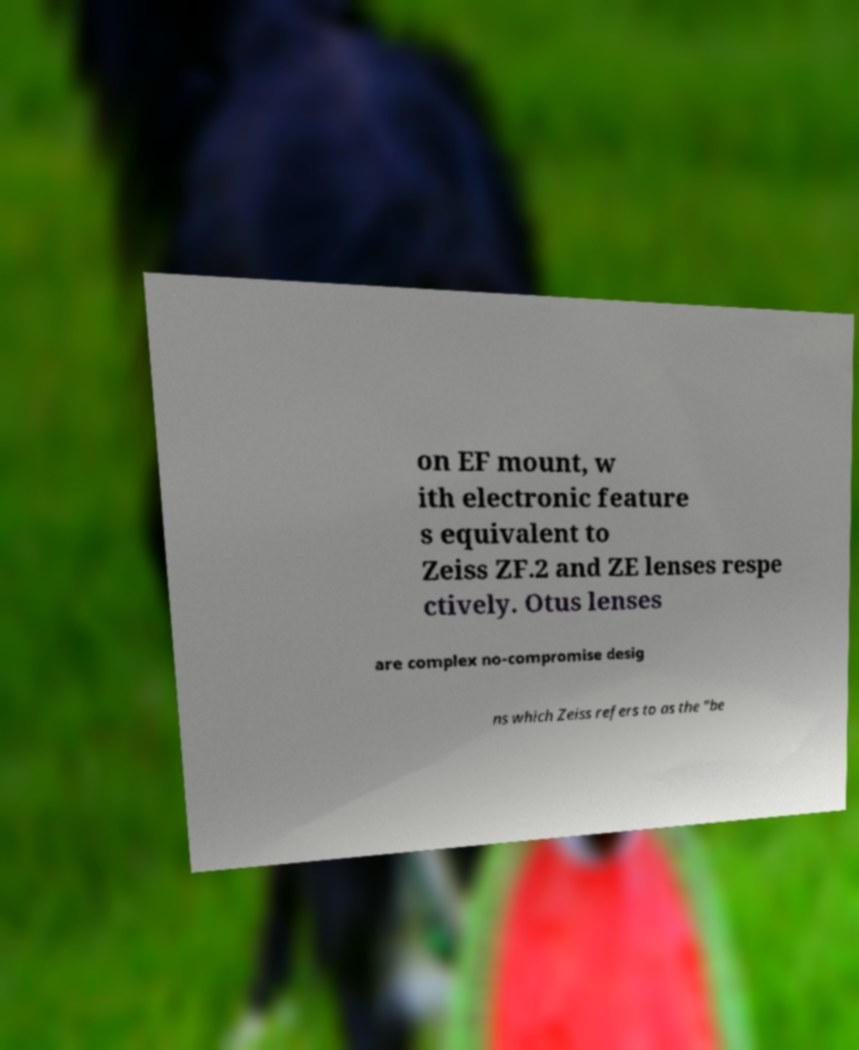For documentation purposes, I need the text within this image transcribed. Could you provide that? on EF mount, w ith electronic feature s equivalent to Zeiss ZF.2 and ZE lenses respe ctively. Otus lenses are complex no-compromise desig ns which Zeiss refers to as the "be 